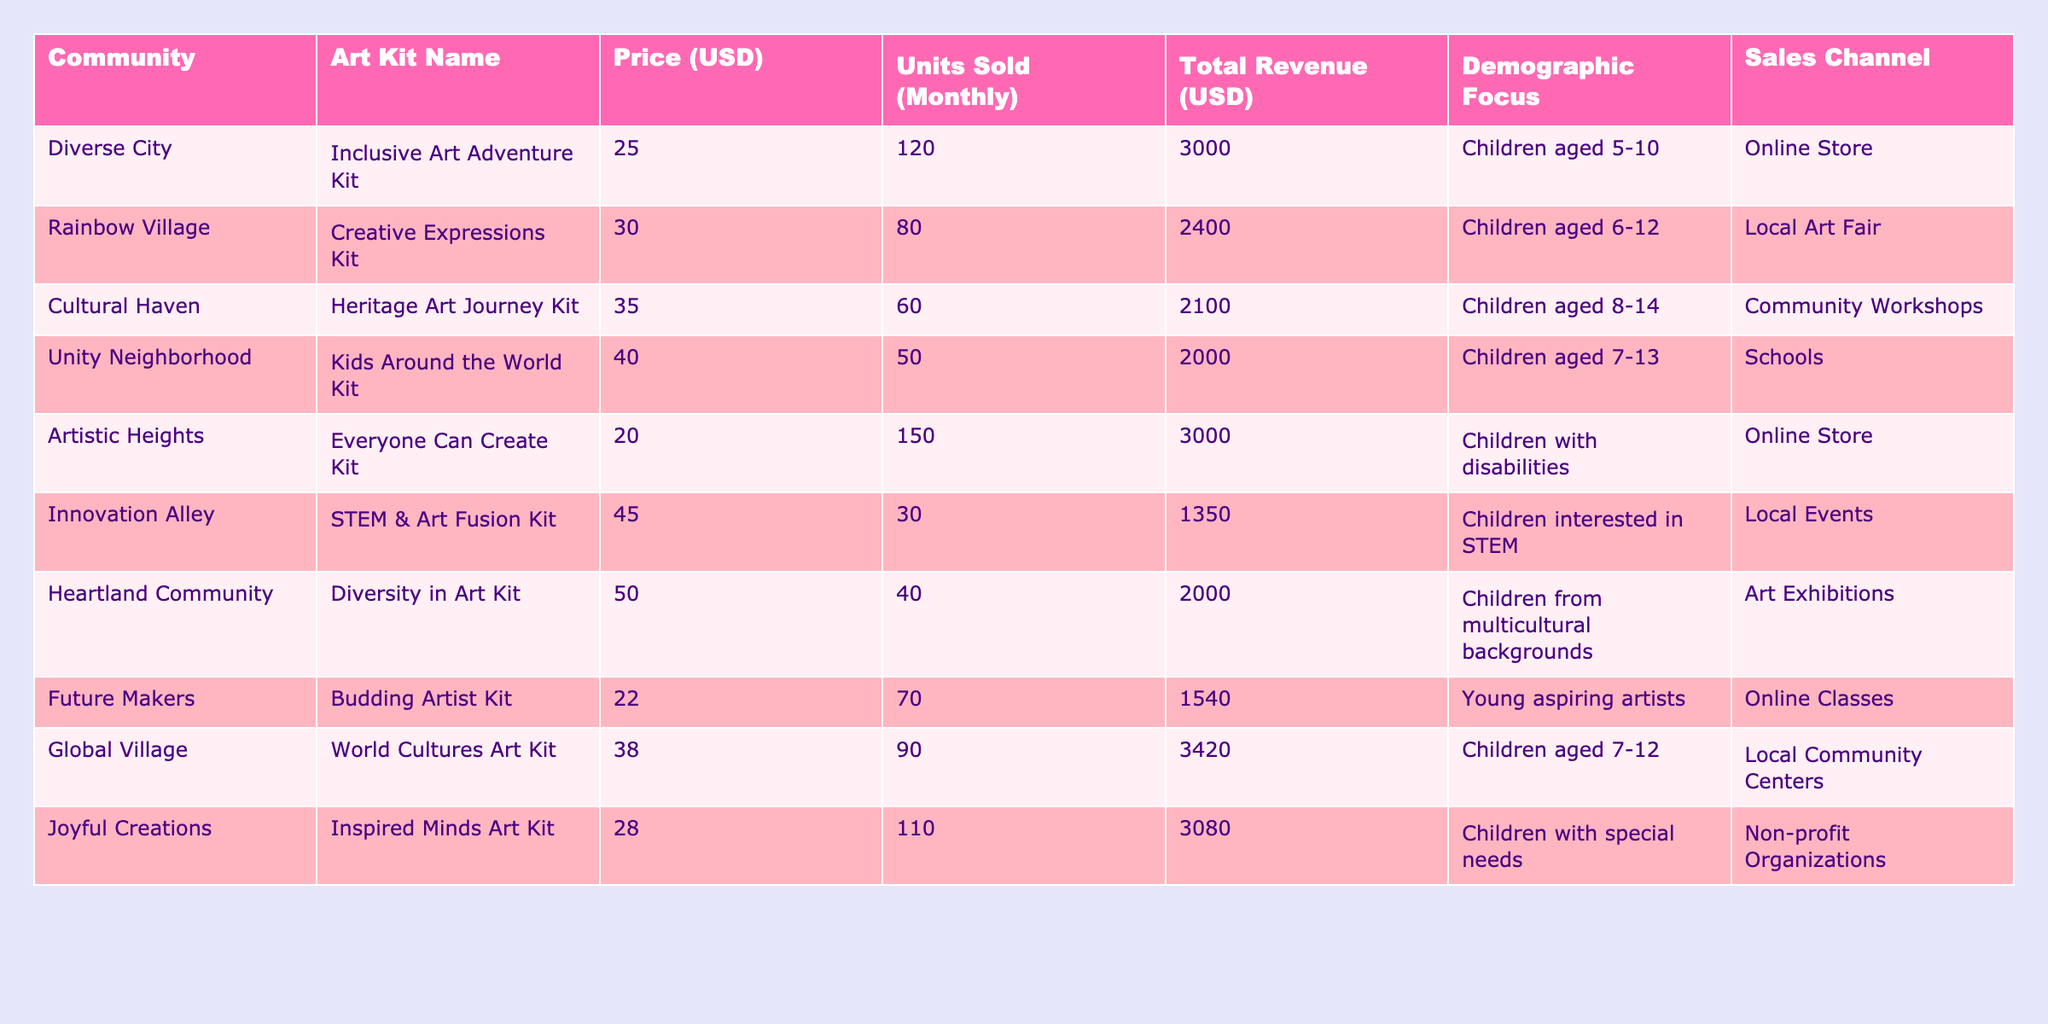What's the total revenue generated from the "Everyone Can Create Kit"? The table shows "Everyone Can Create Kit" with a total revenue of 3000 USD listed under Total Revenue.
Answer: 3000 USD Which art kit focused on children aged 8-14 generated the least revenue? The "Heritage Art Journey Kit" is targeted at children aged 8-14 and has a total revenue of 2100 USD, which is less than the revenue of any other kit in that age bracket.
Answer: Heritage Art Journey Kit What is the price of the "Creative Expressions Kit"? By searching the "Creative Expressions Kit" in the table, the price listed under the Price (USD) column is 30 USD.
Answer: 30 USD How many units of the "Joyful Creations" kit were sold compared to the "Budding Artist Kit"? The "Joyful Creations Kit" sold 110 units, while the "Budding Artist Kit" sold 70 units. The difference is 110 - 70 = 40 units more sold for the Joyful Creations Kit.
Answer: 40 units Which sales channel has the highest revenue-generating art kit? "Online Store" features the "Everyone Can Create Kit" and "Inclusive Art Adventure Kit," both generating 3000 USD each, which is higher than any kit from other sales channels.
Answer: Online Store What is the average price of all art kits? The total prices of the kits are 25 + 30 + 35 + 40 + 20 + 45 + 50 + 22 + 38 + 28 = 363 USD. There are 10 kits, so the average price is 363 / 10 = 36.3 USD.
Answer: 36.3 USD Did any kits focus on children with disabilities? Yes, the "Everyone Can Create Kit" specifically targets children with disabilities, confirming that a kit is indeed focused on this demographic.
Answer: Yes What is the total revenue from art kits targeting children aged 5-10? The "Inclusive Art Adventure Kit" targets this demographic with a revenue of 3000 USD, making the total from this group 3000 USD since it’s the only kit listed for that age range.
Answer: 3000 USD Which community generated the highest revenue from their art kits? The "Global Village" community sold the "World Cultures Art Kit," generating a revenue of 3420 USD, which is the highest compared to other communities.
Answer: Global Village What percentage does the "STEM & Art Fusion Kit" contribute to the total revenue of all kits? The total revenue for all kits is 3000 + 2400 + 2100 + 2000 + 3000 + 1350 + 2000 + 1540 + 3420 + 3080 = 23,890 USD. The revenue from the "STEM & Art Fusion Kit" is 1350 USD, which is (1350 / 23890) * 100 = 5.65%.
Answer: 5.65% How many kits were sold in total across all communities? The total number of units for each kit can be summed up: 120 + 80 + 60 + 50 + 150 + 30 + 40 + 70 + 90 + 110 = 800 units sold in total.
Answer: 800 units 